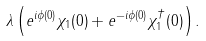Convert formula to latex. <formula><loc_0><loc_0><loc_500><loc_500>\lambda \left ( e ^ { i \phi ( 0 ) } \chi _ { 1 } ( 0 ) + e ^ { - i \phi ( 0 ) } \chi _ { 1 } ^ { \dagger } ( 0 ) \right ) .</formula> 